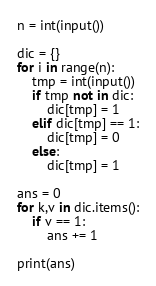<code> <loc_0><loc_0><loc_500><loc_500><_Python_>n = int(input())

dic = {}
for i in range(n):
    tmp = int(input())
    if tmp not in dic:
        dic[tmp] = 1
    elif dic[tmp] == 1:
        dic[tmp] = 0
    else:
        dic[tmp] = 1

ans = 0
for k,v in dic.items():
    if v == 1:
        ans += 1

print(ans)
</code> 